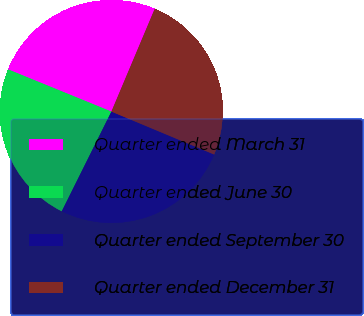Convert chart to OTSL. <chart><loc_0><loc_0><loc_500><loc_500><pie_chart><fcel>Quarter ended March 31<fcel>Quarter ended June 30<fcel>Quarter ended September 30<fcel>Quarter ended December 31<nl><fcel>25.18%<fcel>23.82%<fcel>26.05%<fcel>24.95%<nl></chart> 